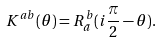Convert formula to latex. <formula><loc_0><loc_0><loc_500><loc_500>K ^ { a b } ( \theta ) = R ^ { b } _ { \bar { a } } ( i \frac { \pi } { 2 } - \theta ) .</formula> 